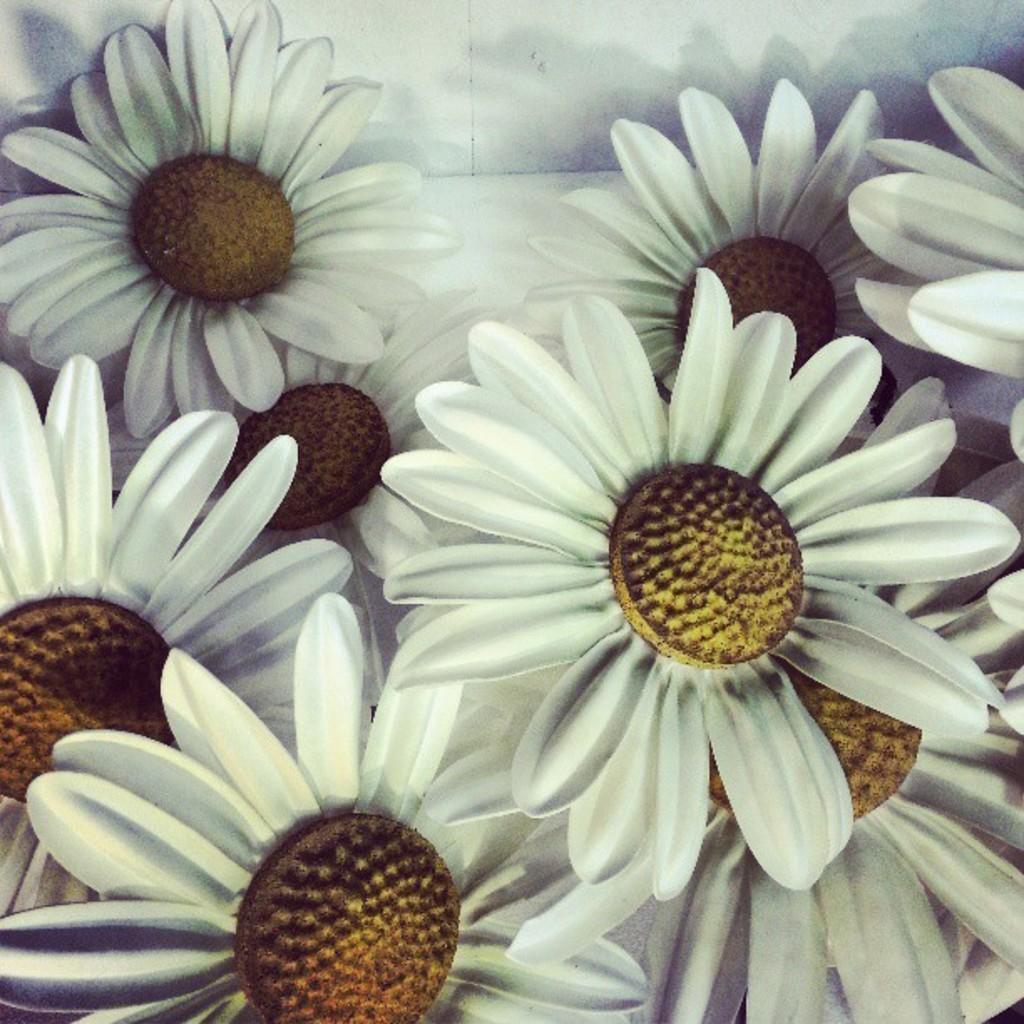Can you describe this image briefly? In the image there are many artificial flowers kept on the floor, the flowers are of white color. 